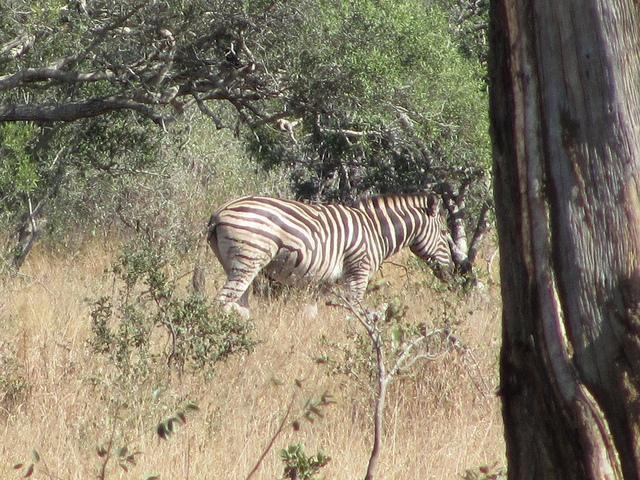How many zebras?
Give a very brief answer. 1. How many zebras are shown?
Give a very brief answer. 1. How many people reading newspapers are there?
Give a very brief answer. 0. 